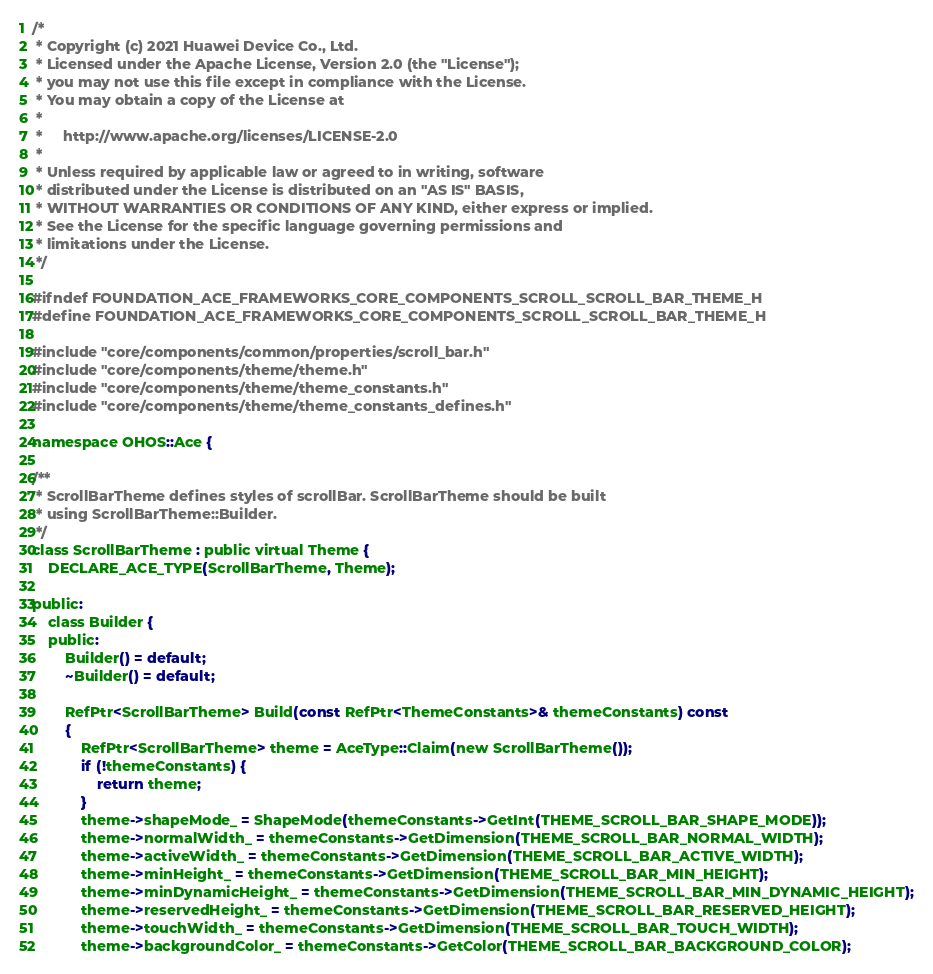Convert code to text. <code><loc_0><loc_0><loc_500><loc_500><_C_>/*
 * Copyright (c) 2021 Huawei Device Co., Ltd.
 * Licensed under the Apache License, Version 2.0 (the "License");
 * you may not use this file except in compliance with the License.
 * You may obtain a copy of the License at
 *
 *     http://www.apache.org/licenses/LICENSE-2.0
 *
 * Unless required by applicable law or agreed to in writing, software
 * distributed under the License is distributed on an "AS IS" BASIS,
 * WITHOUT WARRANTIES OR CONDITIONS OF ANY KIND, either express or implied.
 * See the License for the specific language governing permissions and
 * limitations under the License.
 */

#ifndef FOUNDATION_ACE_FRAMEWORKS_CORE_COMPONENTS_SCROLL_SCROLL_BAR_THEME_H
#define FOUNDATION_ACE_FRAMEWORKS_CORE_COMPONENTS_SCROLL_SCROLL_BAR_THEME_H

#include "core/components/common/properties/scroll_bar.h"
#include "core/components/theme/theme.h"
#include "core/components/theme/theme_constants.h"
#include "core/components/theme/theme_constants_defines.h"

namespace OHOS::Ace {

/**
 * ScrollBarTheme defines styles of scrollBar. ScrollBarTheme should be built
 * using ScrollBarTheme::Builder.
 */
class ScrollBarTheme : public virtual Theme {
    DECLARE_ACE_TYPE(ScrollBarTheme, Theme);

public:
    class Builder {
    public:
        Builder() = default;
        ~Builder() = default;

        RefPtr<ScrollBarTheme> Build(const RefPtr<ThemeConstants>& themeConstants) const
        {
            RefPtr<ScrollBarTheme> theme = AceType::Claim(new ScrollBarTheme());
            if (!themeConstants) {
                return theme;
            }
            theme->shapeMode_ = ShapeMode(themeConstants->GetInt(THEME_SCROLL_BAR_SHAPE_MODE));
            theme->normalWidth_ = themeConstants->GetDimension(THEME_SCROLL_BAR_NORMAL_WIDTH);
            theme->activeWidth_ = themeConstants->GetDimension(THEME_SCROLL_BAR_ACTIVE_WIDTH);
            theme->minHeight_ = themeConstants->GetDimension(THEME_SCROLL_BAR_MIN_HEIGHT);
            theme->minDynamicHeight_ = themeConstants->GetDimension(THEME_SCROLL_BAR_MIN_DYNAMIC_HEIGHT);
            theme->reservedHeight_ = themeConstants->GetDimension(THEME_SCROLL_BAR_RESERVED_HEIGHT);
            theme->touchWidth_ = themeConstants->GetDimension(THEME_SCROLL_BAR_TOUCH_WIDTH);
            theme->backgroundColor_ = themeConstants->GetColor(THEME_SCROLL_BAR_BACKGROUND_COLOR);</code> 